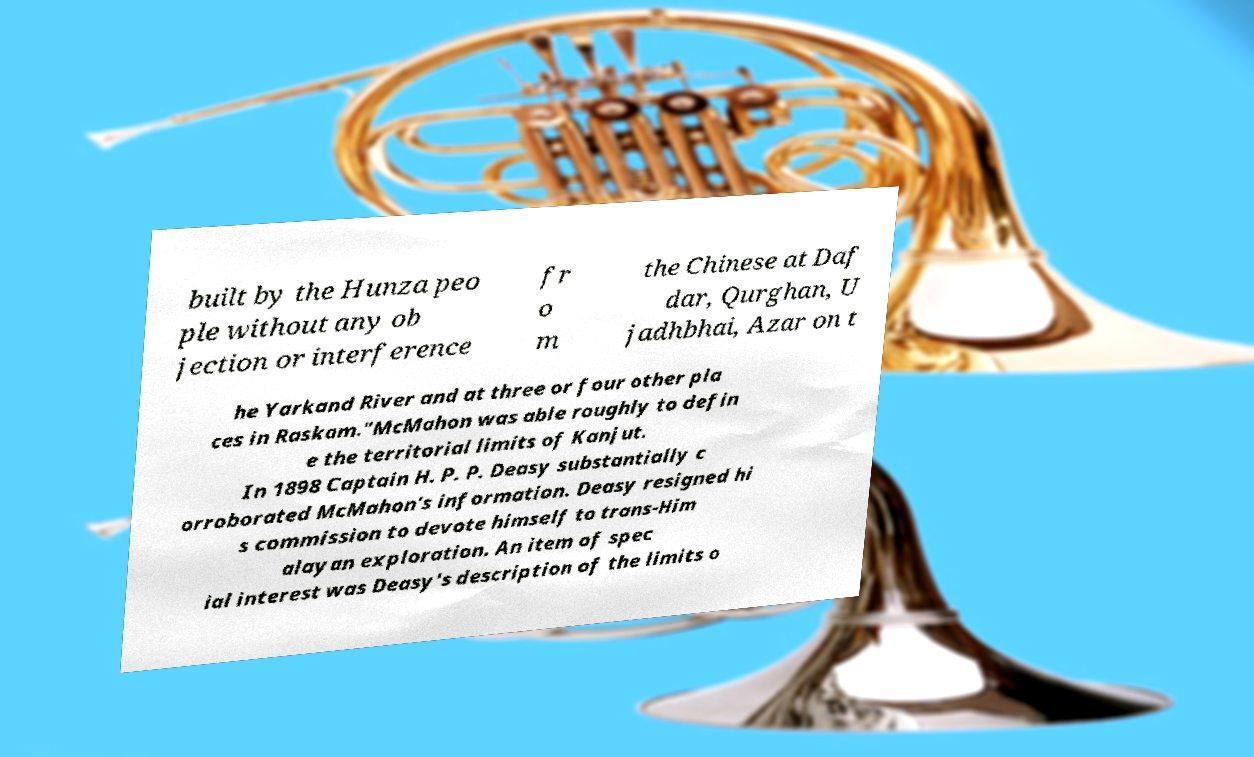Please identify and transcribe the text found in this image. built by the Hunza peo ple without any ob jection or interference fr o m the Chinese at Daf dar, Qurghan, U jadhbhai, Azar on t he Yarkand River and at three or four other pla ces in Raskam."McMahon was able roughly to defin e the territorial limits of Kanjut. In 1898 Captain H. P. P. Deasy substantially c orroborated McMahon's information. Deasy resigned hi s commission to devote himself to trans-Him alayan exploration. An item of spec ial interest was Deasy's description of the limits o 